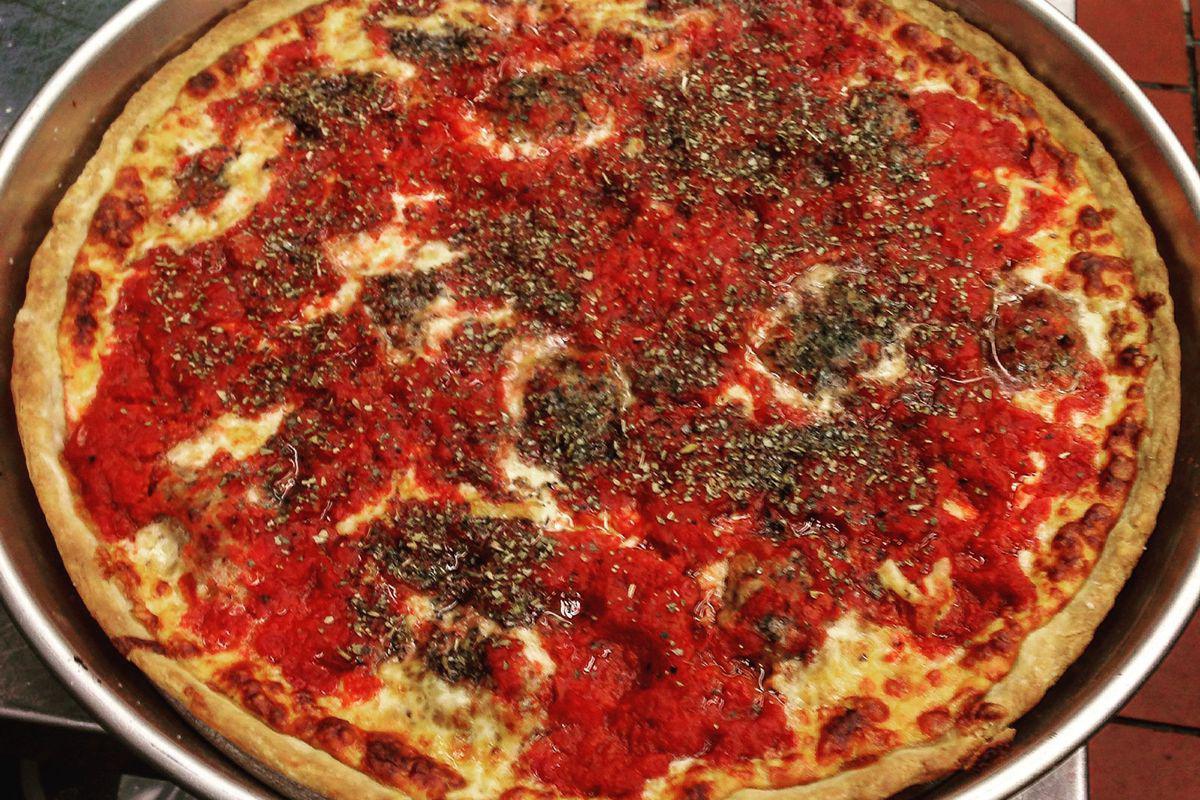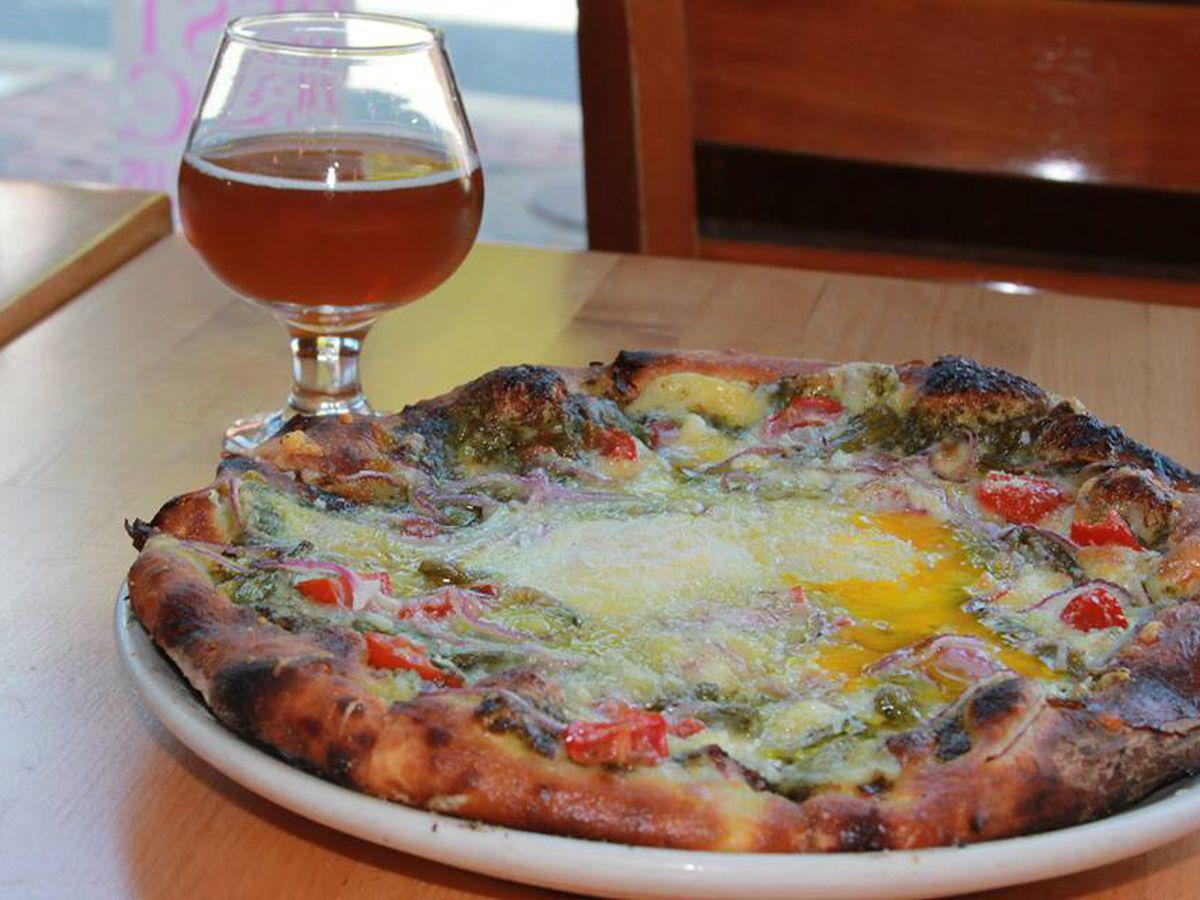The first image is the image on the left, the second image is the image on the right. Examine the images to the left and right. Is the description "Both pizzas are cut into slices." accurate? Answer yes or no. No. 